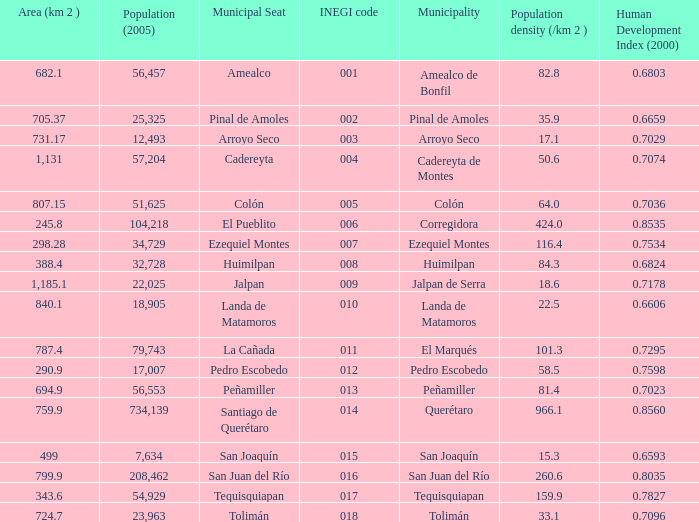WHat is the amount of Human Development Index (2000) that has a Population (2005) of 54,929, and an Area (km 2 ) larger than 343.6? 0.0. I'm looking to parse the entire table for insights. Could you assist me with that? {'header': ['Area (km 2 )', 'Population (2005)', 'Municipal Seat', 'INEGI code', 'Municipality', 'Population density (/km 2 )', 'Human Development Index (2000)'], 'rows': [['682.1', '56,457', 'Amealco', '001', 'Amealco de Bonfil', '82.8', '0.6803'], ['705.37', '25,325', 'Pinal de Amoles', '002', 'Pinal de Amoles', '35.9', '0.6659'], ['731.17', '12,493', 'Arroyo Seco', '003', 'Arroyo Seco', '17.1', '0.7029'], ['1,131', '57,204', 'Cadereyta', '004', 'Cadereyta de Montes', '50.6', '0.7074'], ['807.15', '51,625', 'Colón', '005', 'Colón', '64.0', '0.7036'], ['245.8', '104,218', 'El Pueblito', '006', 'Corregidora', '424.0', '0.8535'], ['298.28', '34,729', 'Ezequiel Montes', '007', 'Ezequiel Montes', '116.4', '0.7534'], ['388.4', '32,728', 'Huimilpan', '008', 'Huimilpan', '84.3', '0.6824'], ['1,185.1', '22,025', 'Jalpan', '009', 'Jalpan de Serra', '18.6', '0.7178'], ['840.1', '18,905', 'Landa de Matamoros', '010', 'Landa de Matamoros', '22.5', '0.6606'], ['787.4', '79,743', 'La Cañada', '011', 'El Marqués', '101.3', '0.7295'], ['290.9', '17,007', 'Pedro Escobedo', '012', 'Pedro Escobedo', '58.5', '0.7598'], ['694.9', '56,553', 'Peñamiller', '013', 'Peñamiller', '81.4', '0.7023'], ['759.9', '734,139', 'Santiago de Querétaro', '014', 'Querétaro', '966.1', '0.8560'], ['499', '7,634', 'San Joaquín', '015', 'San Joaquín', '15.3', '0.6593'], ['799.9', '208,462', 'San Juan del Río', '016', 'San Juan del Río', '260.6', '0.8035'], ['343.6', '54,929', 'Tequisquiapan', '017', 'Tequisquiapan', '159.9', '0.7827'], ['724.7', '23,963', 'Tolimán', '018', 'Tolimán', '33.1', '0.7096']]} 